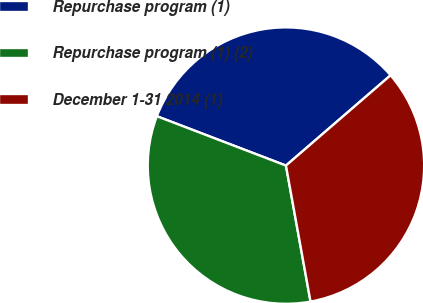Convert chart. <chart><loc_0><loc_0><loc_500><loc_500><pie_chart><fcel>Repurchase program (1)<fcel>Repurchase program (1) (2)<fcel>December 1-31 2014 (1)<nl><fcel>32.86%<fcel>33.66%<fcel>33.49%<nl></chart> 